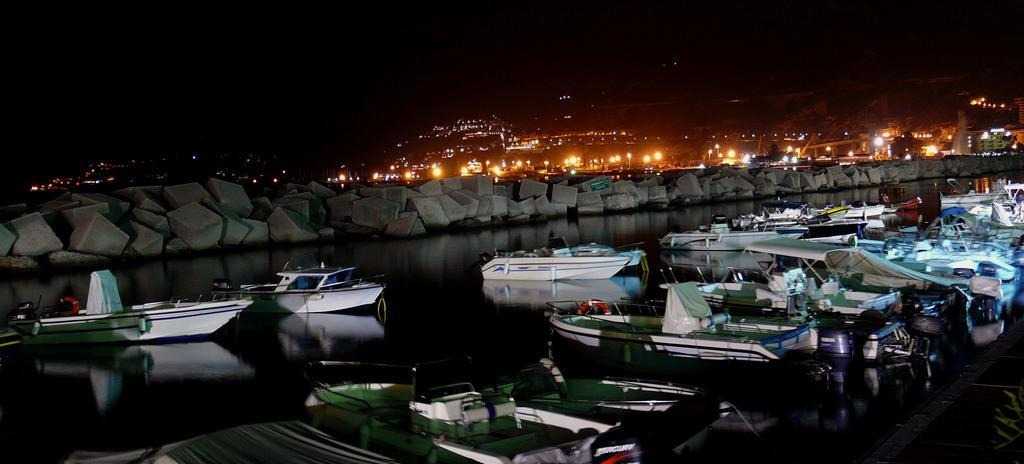Can you describe this image briefly? In this image we can see some boats on the water, there are some rocks, lights, and buildings, and the background is dark. 